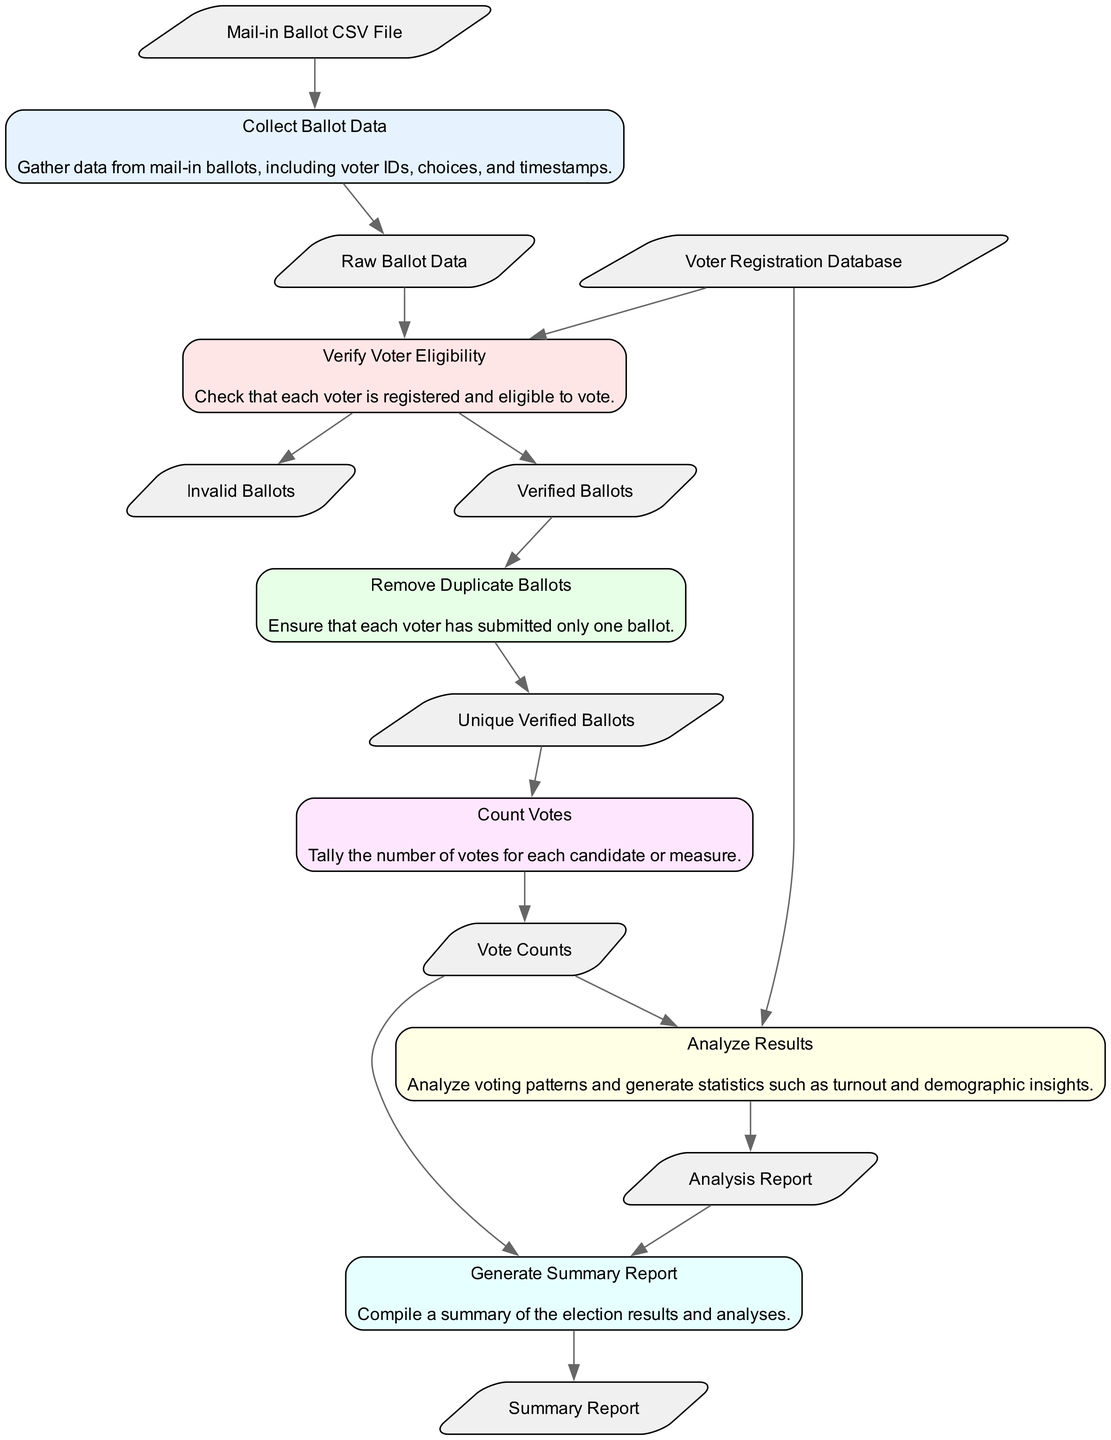What is the first step in the flowchart? The flowchart starts with the "Collect Ballot Data" node, which is the first element in the sequence of steps shown in the diagram.
Answer: Collect Ballot Data How many nodes are there in total? By counting the various nodes present in the flowchart, we find that there are six nodes indicating distinct steps in the process of analyzing election results.
Answer: Six What outputs are generated from the "Verify Voter Eligibility" process? This step produces two outputs: "Verified Ballots" and "Invalid Ballots". These represent the valid and invalid ballots identified during the verification process.
Answer: Verified Ballots, Invalid Ballots Which step comes after "Count Votes"? The "Analyze Results" step follows the "Count Votes" step. This is the immediate next step where the tallied votes are analyzed for insights and statistics.
Answer: Analyze Results What type of data is input to "Generate Summary Report"? "Vote Counts" and "Analysis Report" serve as the input data for the "Generate Summary Report" step, enabling it to compile a summary based on the counted votes and additional analyses.
Answer: Vote Counts, Analysis Report What are the inputs required for "Remove Duplicate Ballots"? The input needed for this step is "Verified Ballots", which consists of ballots that have been confirmed as valid after the eligibility check.
Answer: Verified Ballots What is the last step in the flowchart? The final step of the flowchart is "Generate Summary Report", meaning this is where the processes culminate in a summarized report of the election results.
Answer: Generate Summary Report How many outputs does the "Analyze Results" process yield? The "Analyze Results" step has one output, which is the "Analysis Report", summarizing the insights derived from the vote counts and demographics.
Answer: One Which process directly leads to "Count Votes"? The process "Remove Duplicate Ballots" precedes "Count Votes", ensuring that only unique verified ballots are counted in the vote tally.
Answer: Remove Duplicate Ballots 